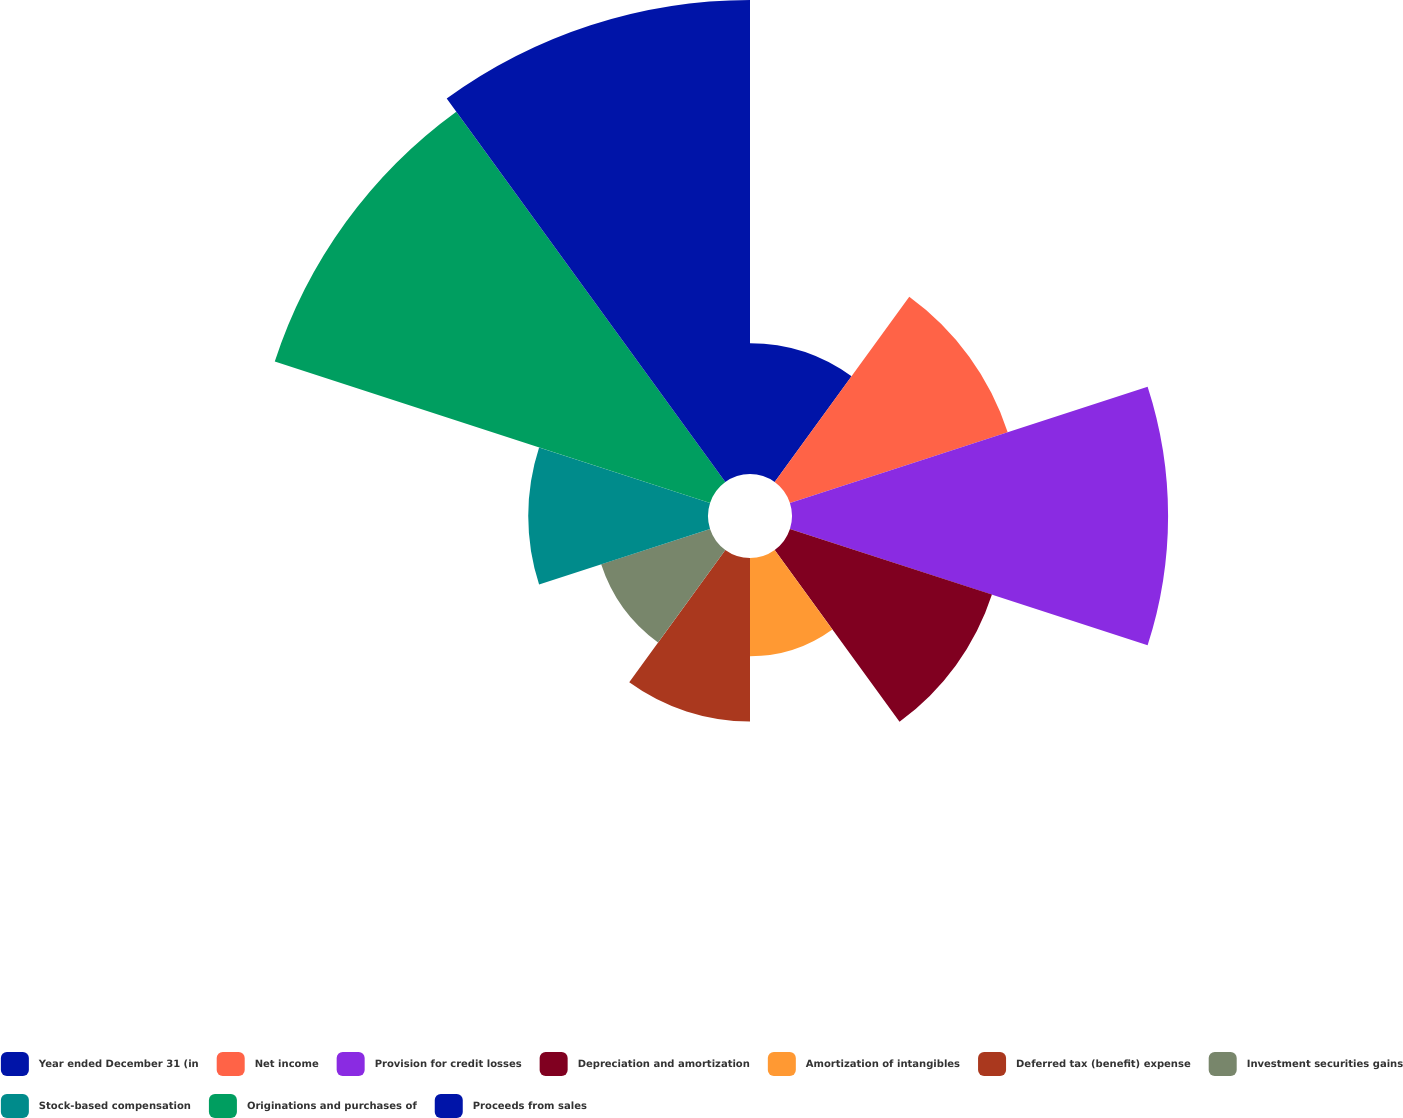Convert chart. <chart><loc_0><loc_0><loc_500><loc_500><pie_chart><fcel>Year ended December 31 (in<fcel>Net income<fcel>Provision for credit losses<fcel>Depreciation and amortization<fcel>Amortization of intangibles<fcel>Deferred tax (benefit) expense<fcel>Investment securities gains<fcel>Stock-based compensation<fcel>Originations and purchases of<fcel>Proceeds from sales<nl><fcel>5.37%<fcel>9.4%<fcel>15.44%<fcel>8.72%<fcel>4.03%<fcel>6.71%<fcel>4.7%<fcel>7.38%<fcel>18.79%<fcel>19.46%<nl></chart> 